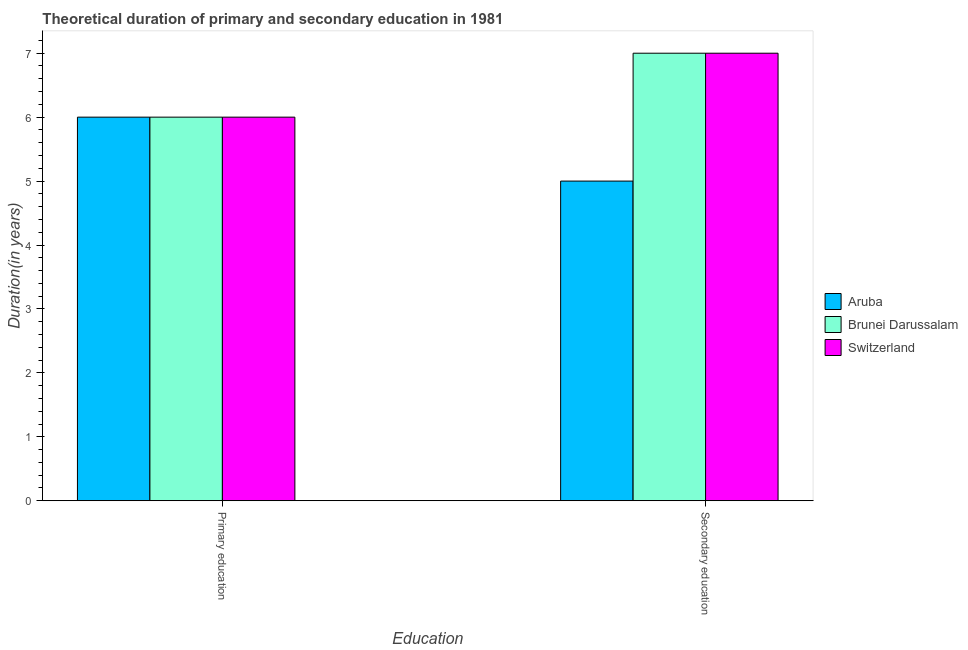Are the number of bars per tick equal to the number of legend labels?
Make the answer very short. Yes. Are the number of bars on each tick of the X-axis equal?
Your answer should be very brief. Yes. How many bars are there on the 1st tick from the left?
Your answer should be very brief. 3. How many bars are there on the 2nd tick from the right?
Give a very brief answer. 3. What is the duration of secondary education in Aruba?
Your answer should be very brief. 5. Across all countries, what is the maximum duration of secondary education?
Give a very brief answer. 7. Across all countries, what is the minimum duration of primary education?
Keep it short and to the point. 6. In which country was the duration of primary education maximum?
Provide a short and direct response. Aruba. In which country was the duration of primary education minimum?
Give a very brief answer. Aruba. What is the total duration of secondary education in the graph?
Offer a terse response. 19. What is the difference between the duration of secondary education in Switzerland and that in Aruba?
Your response must be concise. 2. What is the difference between the duration of secondary education in Aruba and the duration of primary education in Switzerland?
Make the answer very short. -1. What is the average duration of secondary education per country?
Give a very brief answer. 6.33. What is the difference between the duration of primary education and duration of secondary education in Aruba?
Ensure brevity in your answer.  1. In how many countries, is the duration of primary education greater than 2.6 years?
Ensure brevity in your answer.  3. Is the duration of primary education in Brunei Darussalam less than that in Aruba?
Make the answer very short. No. In how many countries, is the duration of secondary education greater than the average duration of secondary education taken over all countries?
Offer a terse response. 2. What does the 3rd bar from the left in Primary education represents?
Provide a succinct answer. Switzerland. What does the 1st bar from the right in Secondary education represents?
Keep it short and to the point. Switzerland. How many bars are there?
Your response must be concise. 6. How many countries are there in the graph?
Provide a short and direct response. 3. What is the difference between two consecutive major ticks on the Y-axis?
Your answer should be compact. 1. Are the values on the major ticks of Y-axis written in scientific E-notation?
Your answer should be compact. No. Does the graph contain grids?
Offer a very short reply. No. Where does the legend appear in the graph?
Make the answer very short. Center right. What is the title of the graph?
Offer a terse response. Theoretical duration of primary and secondary education in 1981. What is the label or title of the X-axis?
Provide a succinct answer. Education. What is the label or title of the Y-axis?
Ensure brevity in your answer.  Duration(in years). What is the Duration(in years) in Aruba in Primary education?
Keep it short and to the point. 6. What is the Duration(in years) of Brunei Darussalam in Primary education?
Offer a terse response. 6. What is the Duration(in years) in Aruba in Secondary education?
Your response must be concise. 5. Across all Education, what is the maximum Duration(in years) in Switzerland?
Give a very brief answer. 7. What is the total Duration(in years) of Brunei Darussalam in the graph?
Keep it short and to the point. 13. What is the total Duration(in years) in Switzerland in the graph?
Make the answer very short. 13. What is the difference between the Duration(in years) in Aruba in Primary education and that in Secondary education?
Provide a short and direct response. 1. What is the difference between the Duration(in years) in Brunei Darussalam in Primary education and that in Secondary education?
Give a very brief answer. -1. What is the difference between the Duration(in years) in Aruba in Primary education and the Duration(in years) in Brunei Darussalam in Secondary education?
Give a very brief answer. -1. What is the difference between the Duration(in years) in Aruba in Primary education and the Duration(in years) in Switzerland in Secondary education?
Provide a succinct answer. -1. What is the average Duration(in years) of Aruba per Education?
Provide a succinct answer. 5.5. What is the average Duration(in years) of Brunei Darussalam per Education?
Provide a succinct answer. 6.5. What is the difference between the Duration(in years) of Aruba and Duration(in years) of Brunei Darussalam in Primary education?
Your answer should be very brief. 0. What is the difference between the Duration(in years) of Aruba and Duration(in years) of Switzerland in Secondary education?
Give a very brief answer. -2. What is the ratio of the Duration(in years) in Brunei Darussalam in Primary education to that in Secondary education?
Your answer should be compact. 0.86. What is the ratio of the Duration(in years) in Switzerland in Primary education to that in Secondary education?
Provide a succinct answer. 0.86. What is the difference between the highest and the second highest Duration(in years) in Brunei Darussalam?
Keep it short and to the point. 1. What is the difference between the highest and the lowest Duration(in years) of Aruba?
Offer a terse response. 1. 